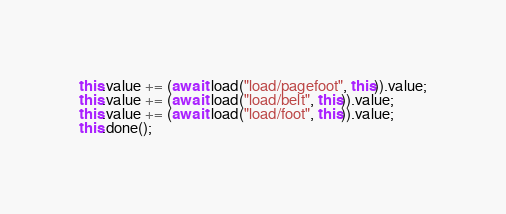Convert code to text. <code><loc_0><loc_0><loc_500><loc_500><_JavaScript_>this.value += (await load("load/pagefoot", this)).value;
this.value += (await load("load/belt", this)).value;
this.value += (await load("load/foot", this)).value;
this.done();
</code> 